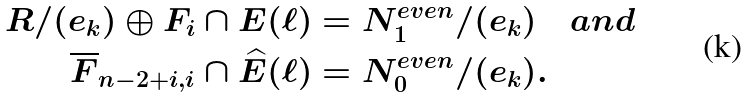Convert formula to latex. <formula><loc_0><loc_0><loc_500><loc_500>R / ( e _ { k } ) \oplus F _ { i } \cap E ( \ell ) & = N _ { 1 } ^ { e v e n } / ( e _ { k } ) \quad a n d \\ \overline { F } _ { n - 2 + i , i } \cap \widehat { E } ( \ell ) & = N _ { 0 } ^ { e v e n } / ( e _ { k } ) .</formula> 